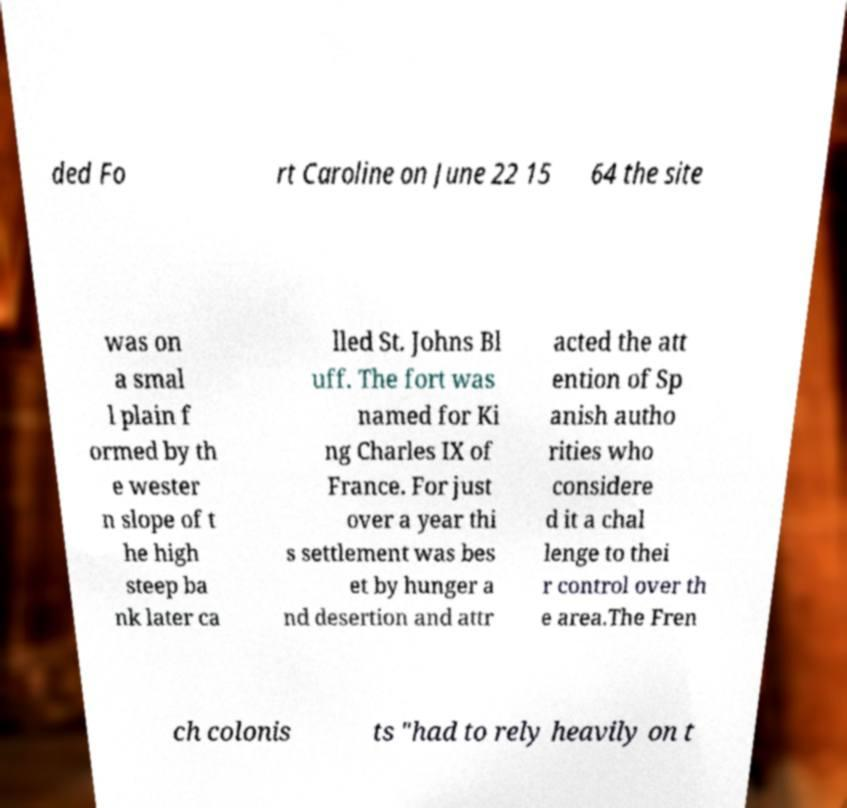Please read and relay the text visible in this image. What does it say? ded Fo rt Caroline on June 22 15 64 the site was on a smal l plain f ormed by th e wester n slope of t he high steep ba nk later ca lled St. Johns Bl uff. The fort was named for Ki ng Charles IX of France. For just over a year thi s settlement was bes et by hunger a nd desertion and attr acted the att ention of Sp anish autho rities who considere d it a chal lenge to thei r control over th e area.The Fren ch colonis ts "had to rely heavily on t 